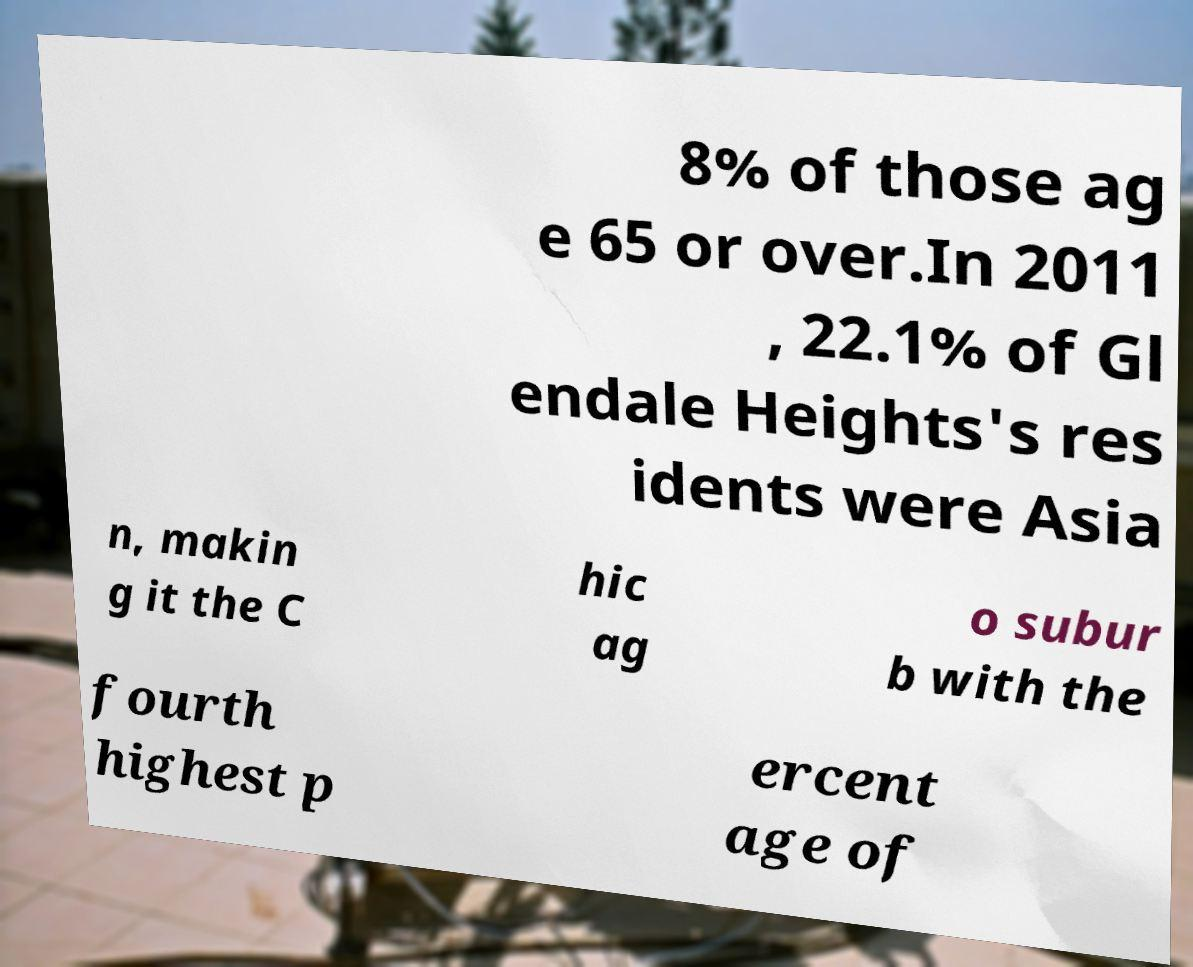Could you assist in decoding the text presented in this image and type it out clearly? 8% of those ag e 65 or over.In 2011 , 22.1% of Gl endale Heights's res idents were Asia n, makin g it the C hic ag o subur b with the fourth highest p ercent age of 